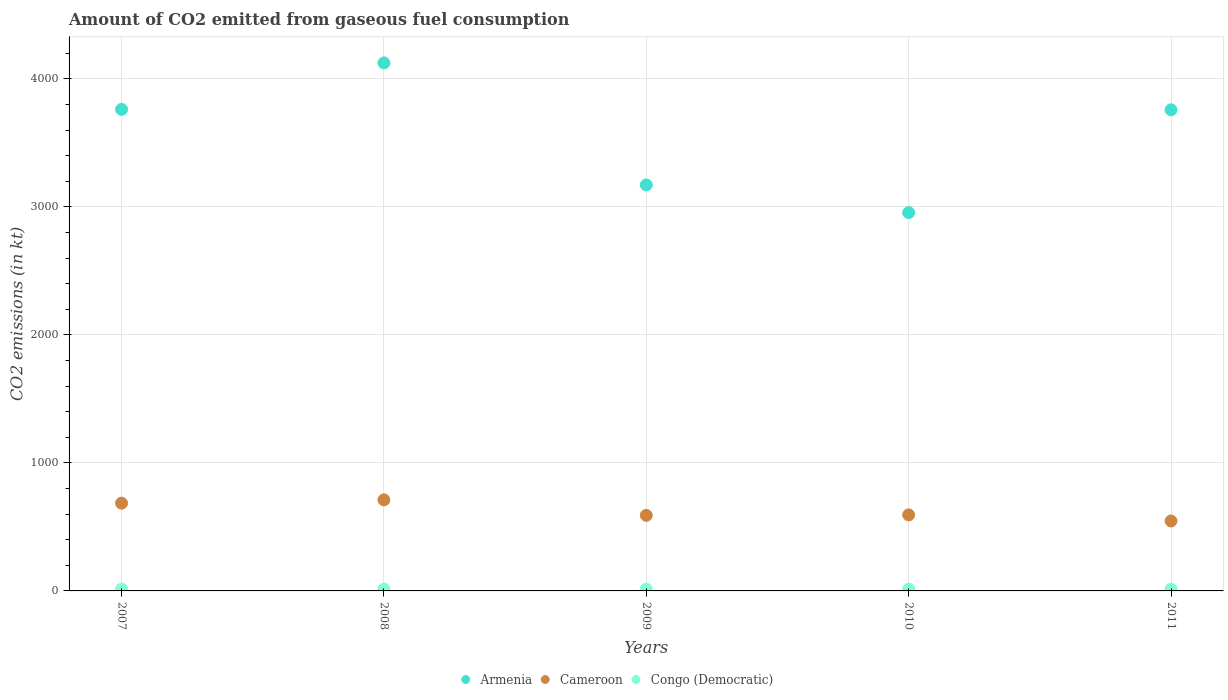How many different coloured dotlines are there?
Keep it short and to the point. 3. What is the amount of CO2 emitted in Armenia in 2010?
Give a very brief answer. 2955.6. Across all years, what is the maximum amount of CO2 emitted in Congo (Democratic)?
Your response must be concise. 14.67. Across all years, what is the minimum amount of CO2 emitted in Cameroon?
Your answer should be compact. 546.38. In which year was the amount of CO2 emitted in Cameroon minimum?
Offer a very short reply. 2011. What is the total amount of CO2 emitted in Congo (Democratic) in the graph?
Make the answer very short. 73.34. What is the difference between the amount of CO2 emitted in Cameroon in 2008 and that in 2010?
Keep it short and to the point. 117.34. What is the difference between the amount of CO2 emitted in Armenia in 2009 and the amount of CO2 emitted in Cameroon in 2007?
Offer a terse response. 2486.23. What is the average amount of CO2 emitted in Armenia per year?
Offer a very short reply. 3554.79. In the year 2008, what is the difference between the amount of CO2 emitted in Armenia and amount of CO2 emitted in Cameroon?
Make the answer very short. 3413.98. In how many years, is the amount of CO2 emitted in Cameroon greater than 600 kt?
Give a very brief answer. 2. What is the ratio of the amount of CO2 emitted in Armenia in 2007 to that in 2009?
Provide a succinct answer. 1.19. Is the difference between the amount of CO2 emitted in Armenia in 2007 and 2011 greater than the difference between the amount of CO2 emitted in Cameroon in 2007 and 2011?
Make the answer very short. No. What is the difference between the highest and the second highest amount of CO2 emitted in Congo (Democratic)?
Your response must be concise. 0. What is the difference between the highest and the lowest amount of CO2 emitted in Armenia?
Offer a very short reply. 1169.77. In how many years, is the amount of CO2 emitted in Cameroon greater than the average amount of CO2 emitted in Cameroon taken over all years?
Keep it short and to the point. 2. Does the amount of CO2 emitted in Armenia monotonically increase over the years?
Provide a short and direct response. No. Is the amount of CO2 emitted in Congo (Democratic) strictly less than the amount of CO2 emitted in Cameroon over the years?
Give a very brief answer. Yes. What is the difference between two consecutive major ticks on the Y-axis?
Offer a terse response. 1000. Are the values on the major ticks of Y-axis written in scientific E-notation?
Offer a very short reply. No. Does the graph contain grids?
Your response must be concise. Yes. How many legend labels are there?
Your response must be concise. 3. What is the title of the graph?
Offer a terse response. Amount of CO2 emitted from gaseous fuel consumption. What is the label or title of the X-axis?
Ensure brevity in your answer.  Years. What is the label or title of the Y-axis?
Ensure brevity in your answer.  CO2 emissions (in kt). What is the CO2 emissions (in kt) in Armenia in 2007?
Make the answer very short. 3762.34. What is the CO2 emissions (in kt) of Cameroon in 2007?
Make the answer very short. 685.73. What is the CO2 emissions (in kt) of Congo (Democratic) in 2007?
Provide a succinct answer. 14.67. What is the CO2 emissions (in kt) in Armenia in 2008?
Offer a very short reply. 4125.38. What is the CO2 emissions (in kt) in Cameroon in 2008?
Your answer should be compact. 711.4. What is the CO2 emissions (in kt) in Congo (Democratic) in 2008?
Your response must be concise. 14.67. What is the CO2 emissions (in kt) of Armenia in 2009?
Make the answer very short. 3171.95. What is the CO2 emissions (in kt) in Cameroon in 2009?
Keep it short and to the point. 590.39. What is the CO2 emissions (in kt) of Congo (Democratic) in 2009?
Provide a short and direct response. 14.67. What is the CO2 emissions (in kt) of Armenia in 2010?
Your answer should be compact. 2955.6. What is the CO2 emissions (in kt) in Cameroon in 2010?
Provide a short and direct response. 594.05. What is the CO2 emissions (in kt) of Congo (Democratic) in 2010?
Keep it short and to the point. 14.67. What is the CO2 emissions (in kt) of Armenia in 2011?
Your answer should be compact. 3758.68. What is the CO2 emissions (in kt) of Cameroon in 2011?
Make the answer very short. 546.38. What is the CO2 emissions (in kt) in Congo (Democratic) in 2011?
Your answer should be very brief. 14.67. Across all years, what is the maximum CO2 emissions (in kt) in Armenia?
Your answer should be very brief. 4125.38. Across all years, what is the maximum CO2 emissions (in kt) in Cameroon?
Your answer should be compact. 711.4. Across all years, what is the maximum CO2 emissions (in kt) of Congo (Democratic)?
Offer a very short reply. 14.67. Across all years, what is the minimum CO2 emissions (in kt) of Armenia?
Your answer should be compact. 2955.6. Across all years, what is the minimum CO2 emissions (in kt) in Cameroon?
Offer a very short reply. 546.38. Across all years, what is the minimum CO2 emissions (in kt) in Congo (Democratic)?
Make the answer very short. 14.67. What is the total CO2 emissions (in kt) of Armenia in the graph?
Ensure brevity in your answer.  1.78e+04. What is the total CO2 emissions (in kt) of Cameroon in the graph?
Ensure brevity in your answer.  3127.95. What is the total CO2 emissions (in kt) of Congo (Democratic) in the graph?
Make the answer very short. 73.34. What is the difference between the CO2 emissions (in kt) of Armenia in 2007 and that in 2008?
Provide a succinct answer. -363.03. What is the difference between the CO2 emissions (in kt) of Cameroon in 2007 and that in 2008?
Your response must be concise. -25.67. What is the difference between the CO2 emissions (in kt) of Armenia in 2007 and that in 2009?
Ensure brevity in your answer.  590.39. What is the difference between the CO2 emissions (in kt) in Cameroon in 2007 and that in 2009?
Your answer should be compact. 95.34. What is the difference between the CO2 emissions (in kt) of Armenia in 2007 and that in 2010?
Your response must be concise. 806.74. What is the difference between the CO2 emissions (in kt) of Cameroon in 2007 and that in 2010?
Offer a terse response. 91.67. What is the difference between the CO2 emissions (in kt) in Congo (Democratic) in 2007 and that in 2010?
Keep it short and to the point. 0. What is the difference between the CO2 emissions (in kt) of Armenia in 2007 and that in 2011?
Your response must be concise. 3.67. What is the difference between the CO2 emissions (in kt) in Cameroon in 2007 and that in 2011?
Provide a succinct answer. 139.35. What is the difference between the CO2 emissions (in kt) of Congo (Democratic) in 2007 and that in 2011?
Provide a short and direct response. 0. What is the difference between the CO2 emissions (in kt) in Armenia in 2008 and that in 2009?
Give a very brief answer. 953.42. What is the difference between the CO2 emissions (in kt) in Cameroon in 2008 and that in 2009?
Offer a very short reply. 121.01. What is the difference between the CO2 emissions (in kt) in Armenia in 2008 and that in 2010?
Offer a terse response. 1169.77. What is the difference between the CO2 emissions (in kt) in Cameroon in 2008 and that in 2010?
Provide a short and direct response. 117.34. What is the difference between the CO2 emissions (in kt) of Congo (Democratic) in 2008 and that in 2010?
Keep it short and to the point. 0. What is the difference between the CO2 emissions (in kt) of Armenia in 2008 and that in 2011?
Give a very brief answer. 366.7. What is the difference between the CO2 emissions (in kt) in Cameroon in 2008 and that in 2011?
Give a very brief answer. 165.01. What is the difference between the CO2 emissions (in kt) in Congo (Democratic) in 2008 and that in 2011?
Give a very brief answer. 0. What is the difference between the CO2 emissions (in kt) of Armenia in 2009 and that in 2010?
Provide a short and direct response. 216.35. What is the difference between the CO2 emissions (in kt) of Cameroon in 2009 and that in 2010?
Offer a very short reply. -3.67. What is the difference between the CO2 emissions (in kt) in Congo (Democratic) in 2009 and that in 2010?
Provide a succinct answer. 0. What is the difference between the CO2 emissions (in kt) of Armenia in 2009 and that in 2011?
Your answer should be compact. -586.72. What is the difference between the CO2 emissions (in kt) in Cameroon in 2009 and that in 2011?
Your response must be concise. 44. What is the difference between the CO2 emissions (in kt) in Armenia in 2010 and that in 2011?
Your response must be concise. -803.07. What is the difference between the CO2 emissions (in kt) of Cameroon in 2010 and that in 2011?
Keep it short and to the point. 47.67. What is the difference between the CO2 emissions (in kt) of Congo (Democratic) in 2010 and that in 2011?
Offer a terse response. 0. What is the difference between the CO2 emissions (in kt) of Armenia in 2007 and the CO2 emissions (in kt) of Cameroon in 2008?
Offer a very short reply. 3050.94. What is the difference between the CO2 emissions (in kt) in Armenia in 2007 and the CO2 emissions (in kt) in Congo (Democratic) in 2008?
Offer a terse response. 3747.67. What is the difference between the CO2 emissions (in kt) in Cameroon in 2007 and the CO2 emissions (in kt) in Congo (Democratic) in 2008?
Offer a very short reply. 671.06. What is the difference between the CO2 emissions (in kt) of Armenia in 2007 and the CO2 emissions (in kt) of Cameroon in 2009?
Provide a succinct answer. 3171.95. What is the difference between the CO2 emissions (in kt) of Armenia in 2007 and the CO2 emissions (in kt) of Congo (Democratic) in 2009?
Keep it short and to the point. 3747.67. What is the difference between the CO2 emissions (in kt) of Cameroon in 2007 and the CO2 emissions (in kt) of Congo (Democratic) in 2009?
Provide a short and direct response. 671.06. What is the difference between the CO2 emissions (in kt) in Armenia in 2007 and the CO2 emissions (in kt) in Cameroon in 2010?
Offer a terse response. 3168.29. What is the difference between the CO2 emissions (in kt) in Armenia in 2007 and the CO2 emissions (in kt) in Congo (Democratic) in 2010?
Give a very brief answer. 3747.67. What is the difference between the CO2 emissions (in kt) in Cameroon in 2007 and the CO2 emissions (in kt) in Congo (Democratic) in 2010?
Your answer should be compact. 671.06. What is the difference between the CO2 emissions (in kt) of Armenia in 2007 and the CO2 emissions (in kt) of Cameroon in 2011?
Your answer should be compact. 3215.96. What is the difference between the CO2 emissions (in kt) of Armenia in 2007 and the CO2 emissions (in kt) of Congo (Democratic) in 2011?
Your answer should be compact. 3747.67. What is the difference between the CO2 emissions (in kt) in Cameroon in 2007 and the CO2 emissions (in kt) in Congo (Democratic) in 2011?
Your response must be concise. 671.06. What is the difference between the CO2 emissions (in kt) in Armenia in 2008 and the CO2 emissions (in kt) in Cameroon in 2009?
Make the answer very short. 3534.99. What is the difference between the CO2 emissions (in kt) of Armenia in 2008 and the CO2 emissions (in kt) of Congo (Democratic) in 2009?
Provide a short and direct response. 4110.71. What is the difference between the CO2 emissions (in kt) in Cameroon in 2008 and the CO2 emissions (in kt) in Congo (Democratic) in 2009?
Provide a succinct answer. 696.73. What is the difference between the CO2 emissions (in kt) of Armenia in 2008 and the CO2 emissions (in kt) of Cameroon in 2010?
Give a very brief answer. 3531.32. What is the difference between the CO2 emissions (in kt) in Armenia in 2008 and the CO2 emissions (in kt) in Congo (Democratic) in 2010?
Make the answer very short. 4110.71. What is the difference between the CO2 emissions (in kt) of Cameroon in 2008 and the CO2 emissions (in kt) of Congo (Democratic) in 2010?
Give a very brief answer. 696.73. What is the difference between the CO2 emissions (in kt) in Armenia in 2008 and the CO2 emissions (in kt) in Cameroon in 2011?
Your answer should be compact. 3578.99. What is the difference between the CO2 emissions (in kt) in Armenia in 2008 and the CO2 emissions (in kt) in Congo (Democratic) in 2011?
Ensure brevity in your answer.  4110.71. What is the difference between the CO2 emissions (in kt) in Cameroon in 2008 and the CO2 emissions (in kt) in Congo (Democratic) in 2011?
Give a very brief answer. 696.73. What is the difference between the CO2 emissions (in kt) in Armenia in 2009 and the CO2 emissions (in kt) in Cameroon in 2010?
Your answer should be very brief. 2577.9. What is the difference between the CO2 emissions (in kt) of Armenia in 2009 and the CO2 emissions (in kt) of Congo (Democratic) in 2010?
Give a very brief answer. 3157.29. What is the difference between the CO2 emissions (in kt) in Cameroon in 2009 and the CO2 emissions (in kt) in Congo (Democratic) in 2010?
Ensure brevity in your answer.  575.72. What is the difference between the CO2 emissions (in kt) in Armenia in 2009 and the CO2 emissions (in kt) in Cameroon in 2011?
Provide a short and direct response. 2625.57. What is the difference between the CO2 emissions (in kt) of Armenia in 2009 and the CO2 emissions (in kt) of Congo (Democratic) in 2011?
Ensure brevity in your answer.  3157.29. What is the difference between the CO2 emissions (in kt) of Cameroon in 2009 and the CO2 emissions (in kt) of Congo (Democratic) in 2011?
Ensure brevity in your answer.  575.72. What is the difference between the CO2 emissions (in kt) in Armenia in 2010 and the CO2 emissions (in kt) in Cameroon in 2011?
Your response must be concise. 2409.22. What is the difference between the CO2 emissions (in kt) of Armenia in 2010 and the CO2 emissions (in kt) of Congo (Democratic) in 2011?
Your answer should be very brief. 2940.93. What is the difference between the CO2 emissions (in kt) in Cameroon in 2010 and the CO2 emissions (in kt) in Congo (Democratic) in 2011?
Provide a succinct answer. 579.39. What is the average CO2 emissions (in kt) in Armenia per year?
Offer a very short reply. 3554.79. What is the average CO2 emissions (in kt) in Cameroon per year?
Ensure brevity in your answer.  625.59. What is the average CO2 emissions (in kt) of Congo (Democratic) per year?
Offer a terse response. 14.67. In the year 2007, what is the difference between the CO2 emissions (in kt) in Armenia and CO2 emissions (in kt) in Cameroon?
Your answer should be compact. 3076.61. In the year 2007, what is the difference between the CO2 emissions (in kt) of Armenia and CO2 emissions (in kt) of Congo (Democratic)?
Offer a very short reply. 3747.67. In the year 2007, what is the difference between the CO2 emissions (in kt) of Cameroon and CO2 emissions (in kt) of Congo (Democratic)?
Make the answer very short. 671.06. In the year 2008, what is the difference between the CO2 emissions (in kt) of Armenia and CO2 emissions (in kt) of Cameroon?
Your answer should be very brief. 3413.98. In the year 2008, what is the difference between the CO2 emissions (in kt) of Armenia and CO2 emissions (in kt) of Congo (Democratic)?
Provide a short and direct response. 4110.71. In the year 2008, what is the difference between the CO2 emissions (in kt) of Cameroon and CO2 emissions (in kt) of Congo (Democratic)?
Provide a short and direct response. 696.73. In the year 2009, what is the difference between the CO2 emissions (in kt) in Armenia and CO2 emissions (in kt) in Cameroon?
Your response must be concise. 2581.57. In the year 2009, what is the difference between the CO2 emissions (in kt) in Armenia and CO2 emissions (in kt) in Congo (Democratic)?
Keep it short and to the point. 3157.29. In the year 2009, what is the difference between the CO2 emissions (in kt) of Cameroon and CO2 emissions (in kt) of Congo (Democratic)?
Offer a very short reply. 575.72. In the year 2010, what is the difference between the CO2 emissions (in kt) of Armenia and CO2 emissions (in kt) of Cameroon?
Provide a short and direct response. 2361.55. In the year 2010, what is the difference between the CO2 emissions (in kt) in Armenia and CO2 emissions (in kt) in Congo (Democratic)?
Your response must be concise. 2940.93. In the year 2010, what is the difference between the CO2 emissions (in kt) in Cameroon and CO2 emissions (in kt) in Congo (Democratic)?
Provide a succinct answer. 579.39. In the year 2011, what is the difference between the CO2 emissions (in kt) of Armenia and CO2 emissions (in kt) of Cameroon?
Provide a short and direct response. 3212.29. In the year 2011, what is the difference between the CO2 emissions (in kt) of Armenia and CO2 emissions (in kt) of Congo (Democratic)?
Give a very brief answer. 3744.01. In the year 2011, what is the difference between the CO2 emissions (in kt) of Cameroon and CO2 emissions (in kt) of Congo (Democratic)?
Provide a succinct answer. 531.72. What is the ratio of the CO2 emissions (in kt) in Armenia in 2007 to that in 2008?
Offer a terse response. 0.91. What is the ratio of the CO2 emissions (in kt) of Cameroon in 2007 to that in 2008?
Your answer should be very brief. 0.96. What is the ratio of the CO2 emissions (in kt) in Congo (Democratic) in 2007 to that in 2008?
Keep it short and to the point. 1. What is the ratio of the CO2 emissions (in kt) in Armenia in 2007 to that in 2009?
Give a very brief answer. 1.19. What is the ratio of the CO2 emissions (in kt) of Cameroon in 2007 to that in 2009?
Ensure brevity in your answer.  1.16. What is the ratio of the CO2 emissions (in kt) of Congo (Democratic) in 2007 to that in 2009?
Your response must be concise. 1. What is the ratio of the CO2 emissions (in kt) in Armenia in 2007 to that in 2010?
Provide a succinct answer. 1.27. What is the ratio of the CO2 emissions (in kt) in Cameroon in 2007 to that in 2010?
Provide a succinct answer. 1.15. What is the ratio of the CO2 emissions (in kt) in Armenia in 2007 to that in 2011?
Your response must be concise. 1. What is the ratio of the CO2 emissions (in kt) in Cameroon in 2007 to that in 2011?
Provide a succinct answer. 1.25. What is the ratio of the CO2 emissions (in kt) of Armenia in 2008 to that in 2009?
Keep it short and to the point. 1.3. What is the ratio of the CO2 emissions (in kt) of Cameroon in 2008 to that in 2009?
Your answer should be compact. 1.21. What is the ratio of the CO2 emissions (in kt) of Congo (Democratic) in 2008 to that in 2009?
Your answer should be compact. 1. What is the ratio of the CO2 emissions (in kt) of Armenia in 2008 to that in 2010?
Provide a succinct answer. 1.4. What is the ratio of the CO2 emissions (in kt) of Cameroon in 2008 to that in 2010?
Provide a succinct answer. 1.2. What is the ratio of the CO2 emissions (in kt) in Congo (Democratic) in 2008 to that in 2010?
Keep it short and to the point. 1. What is the ratio of the CO2 emissions (in kt) in Armenia in 2008 to that in 2011?
Provide a succinct answer. 1.1. What is the ratio of the CO2 emissions (in kt) of Cameroon in 2008 to that in 2011?
Provide a succinct answer. 1.3. What is the ratio of the CO2 emissions (in kt) in Congo (Democratic) in 2008 to that in 2011?
Keep it short and to the point. 1. What is the ratio of the CO2 emissions (in kt) in Armenia in 2009 to that in 2010?
Offer a very short reply. 1.07. What is the ratio of the CO2 emissions (in kt) of Cameroon in 2009 to that in 2010?
Your answer should be very brief. 0.99. What is the ratio of the CO2 emissions (in kt) in Congo (Democratic) in 2009 to that in 2010?
Your answer should be very brief. 1. What is the ratio of the CO2 emissions (in kt) of Armenia in 2009 to that in 2011?
Your response must be concise. 0.84. What is the ratio of the CO2 emissions (in kt) in Cameroon in 2009 to that in 2011?
Offer a very short reply. 1.08. What is the ratio of the CO2 emissions (in kt) of Congo (Democratic) in 2009 to that in 2011?
Make the answer very short. 1. What is the ratio of the CO2 emissions (in kt) in Armenia in 2010 to that in 2011?
Provide a short and direct response. 0.79. What is the ratio of the CO2 emissions (in kt) in Cameroon in 2010 to that in 2011?
Your response must be concise. 1.09. What is the difference between the highest and the second highest CO2 emissions (in kt) of Armenia?
Your response must be concise. 363.03. What is the difference between the highest and the second highest CO2 emissions (in kt) in Cameroon?
Provide a succinct answer. 25.67. What is the difference between the highest and the second highest CO2 emissions (in kt) in Congo (Democratic)?
Keep it short and to the point. 0. What is the difference between the highest and the lowest CO2 emissions (in kt) of Armenia?
Ensure brevity in your answer.  1169.77. What is the difference between the highest and the lowest CO2 emissions (in kt) in Cameroon?
Your response must be concise. 165.01. 